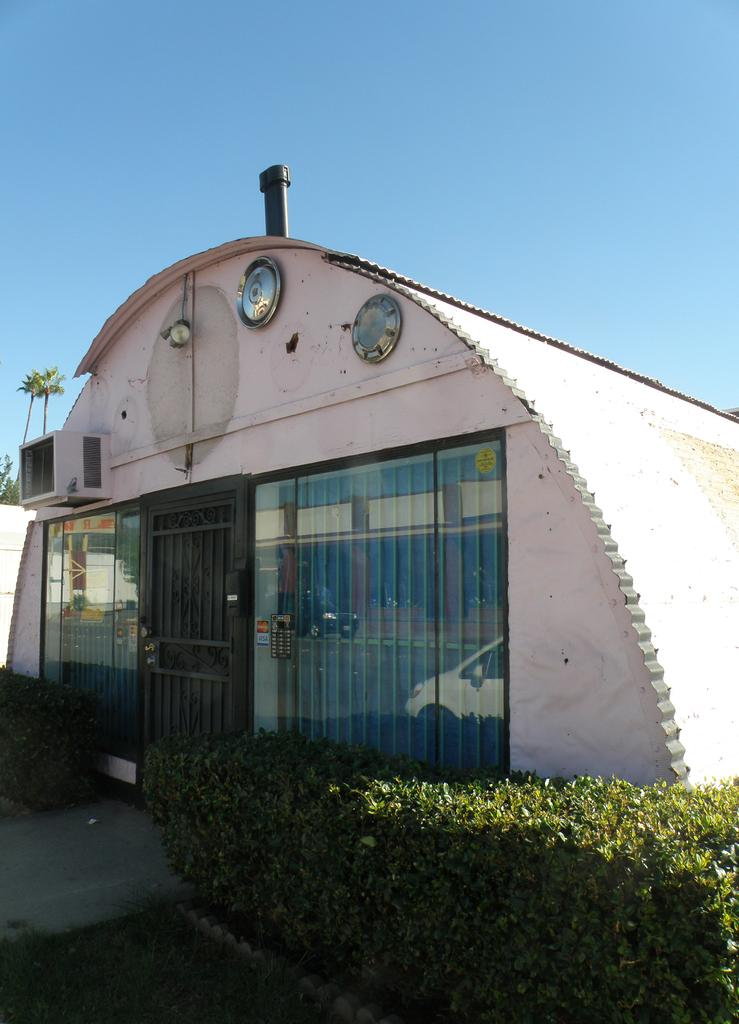What type of structure is present in the image? There is a building in the image. What feature of the building is mentioned in the facts? The building has a door. Are there any objects or items on the building? Yes, there are items on the building. What can be seen near the building? There are bushes near the building. What is visible in the background of the image? The sky and trees are visible in the background of the image. What type of tax is being discussed in the image? There is no mention of tax in the image; it features a building with a door, items on it, bushes nearby, and a background with sky and trees. 